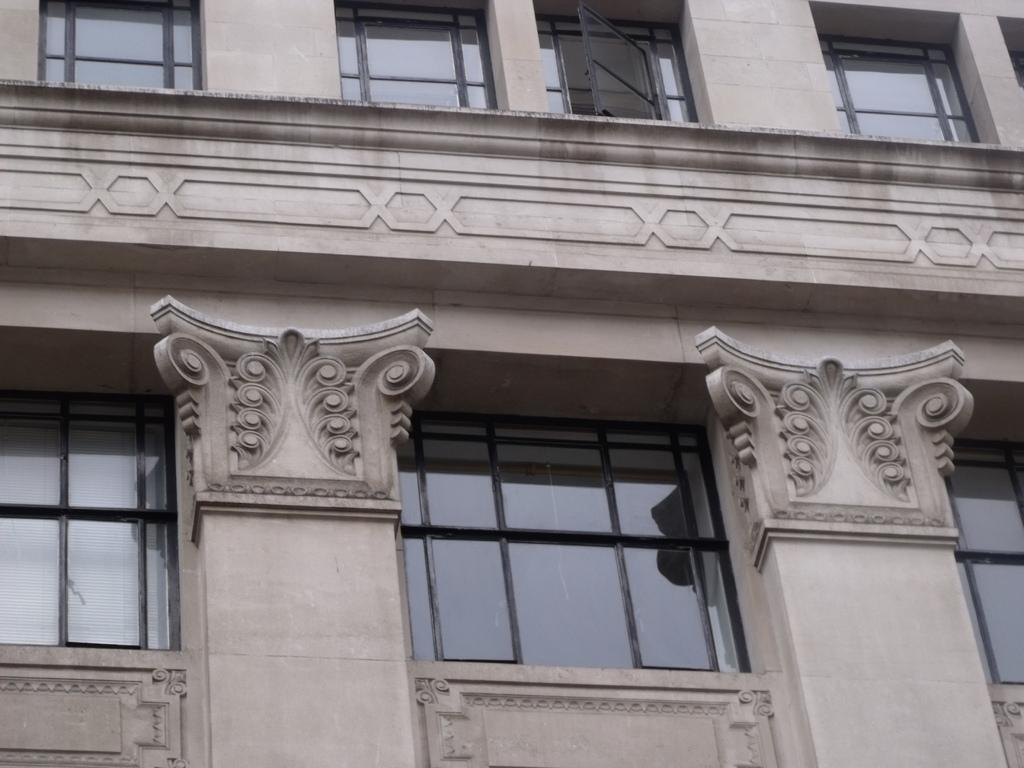What is the main structure visible in the picture? There is a building in the picture. Can you describe any specific features of the building? There is an open window at the top of the building. What type of wax can be seen melting near the authority figure in the image? There is no wax or authority figure present in the image; it only features a building with an open window at the top. 